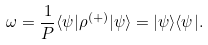Convert formula to latex. <formula><loc_0><loc_0><loc_500><loc_500>\omega = \frac { 1 } { P } \langle \psi | \rho ^ { ( + ) } | \psi \rangle = | \psi \rangle \langle \psi | .</formula> 